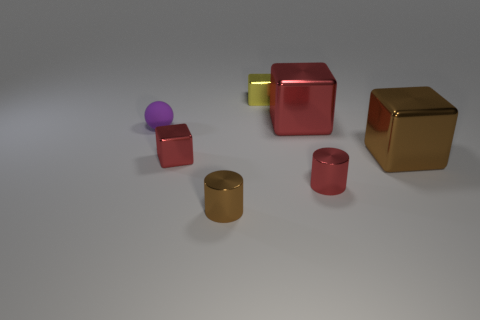Subtract 1 blocks. How many blocks are left? 3 Add 2 red cubes. How many objects exist? 9 Subtract all cubes. How many objects are left? 3 Add 7 large metal things. How many large metal things exist? 9 Subtract 1 purple spheres. How many objects are left? 6 Subtract all blocks. Subtract all green rubber spheres. How many objects are left? 3 Add 6 red cubes. How many red cubes are left? 8 